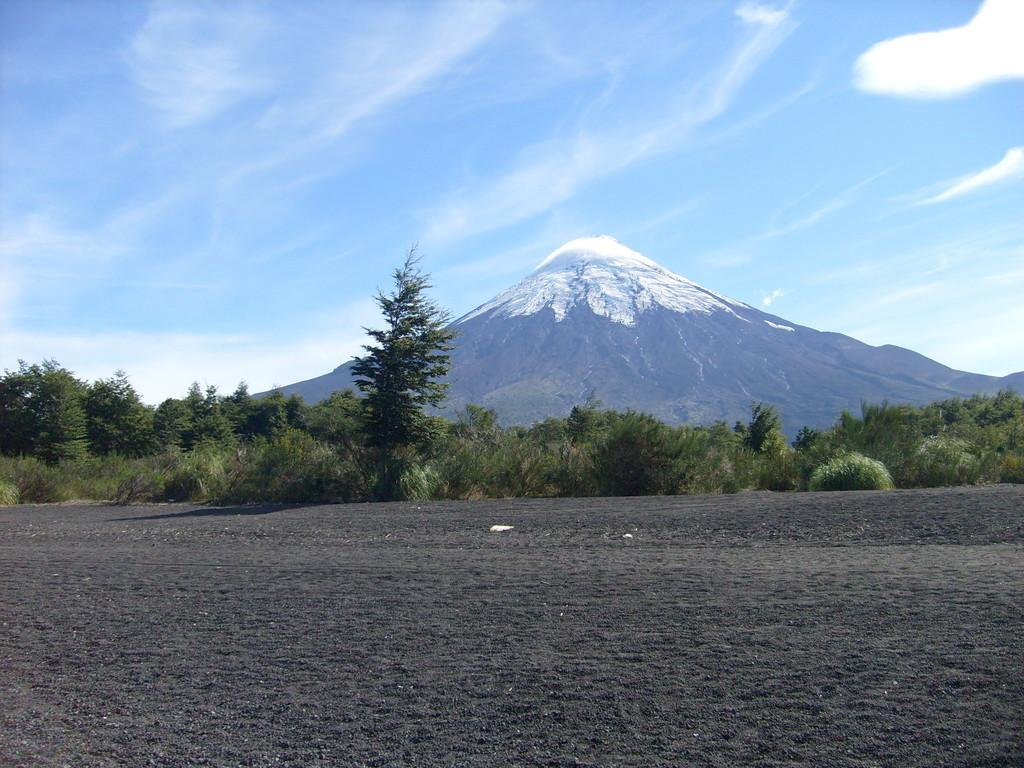How would you summarize this image in a sentence or two? In this image we can see trees, plants, beside that we can see hills, at the bottom we can see the soil, at the top we can see the sky with clouds. 